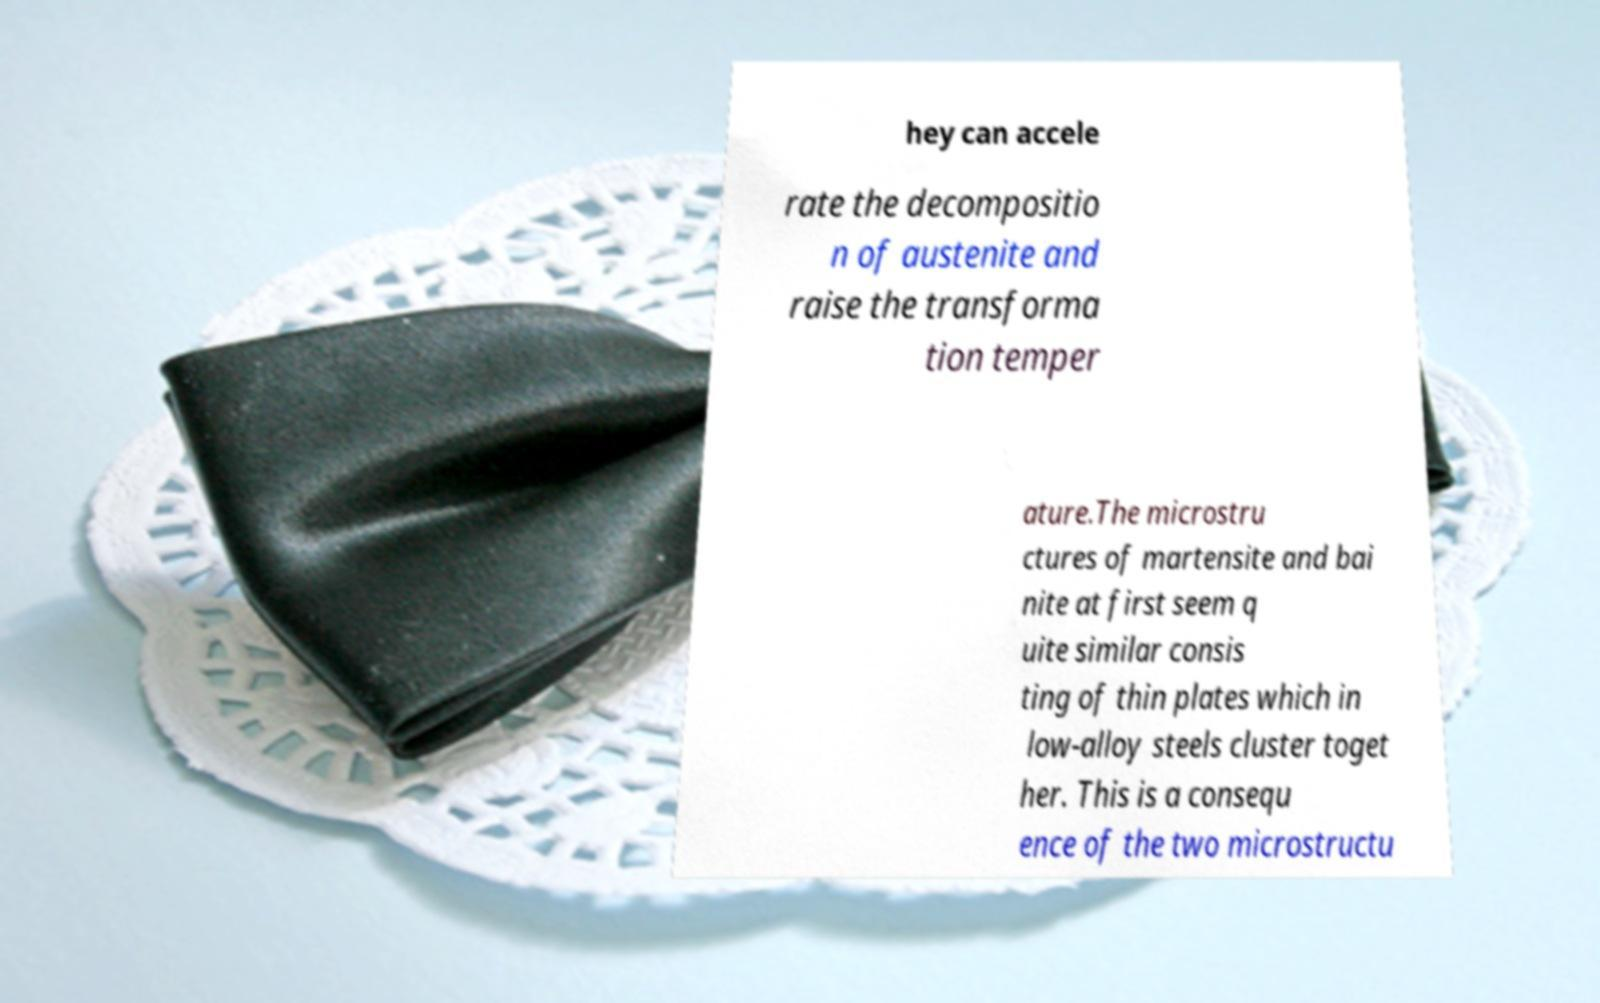Can you read and provide the text displayed in the image?This photo seems to have some interesting text. Can you extract and type it out for me? hey can accele rate the decompositio n of austenite and raise the transforma tion temper ature.The microstru ctures of martensite and bai nite at first seem q uite similar consis ting of thin plates which in low-alloy steels cluster toget her. This is a consequ ence of the two microstructu 